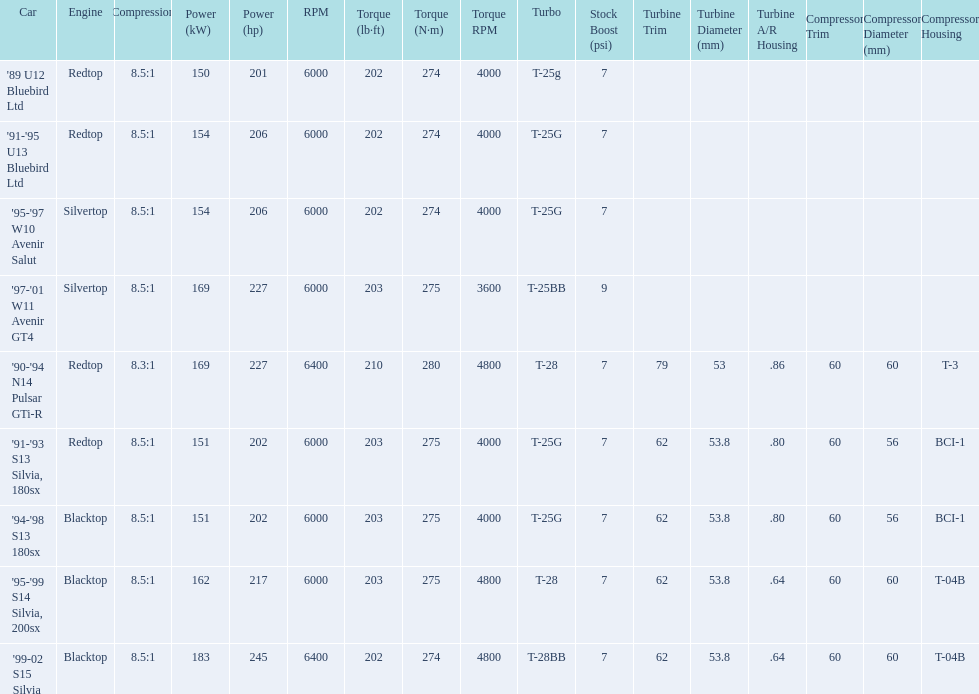Which cars list turbine details? '90-'94 N14 Pulsar GTi-R, '91-'93 S13 Silvia, 180sx, '94-'98 S13 180sx, '95-'99 S14 Silvia, 200sx, '99-02 S15 Silvia. Which of these hit their peak hp at the highest rpm? '90-'94 N14 Pulsar GTi-R, '99-02 S15 Silvia. Of those what is the compression of the only engine that isn't blacktop?? 8.3:1. 